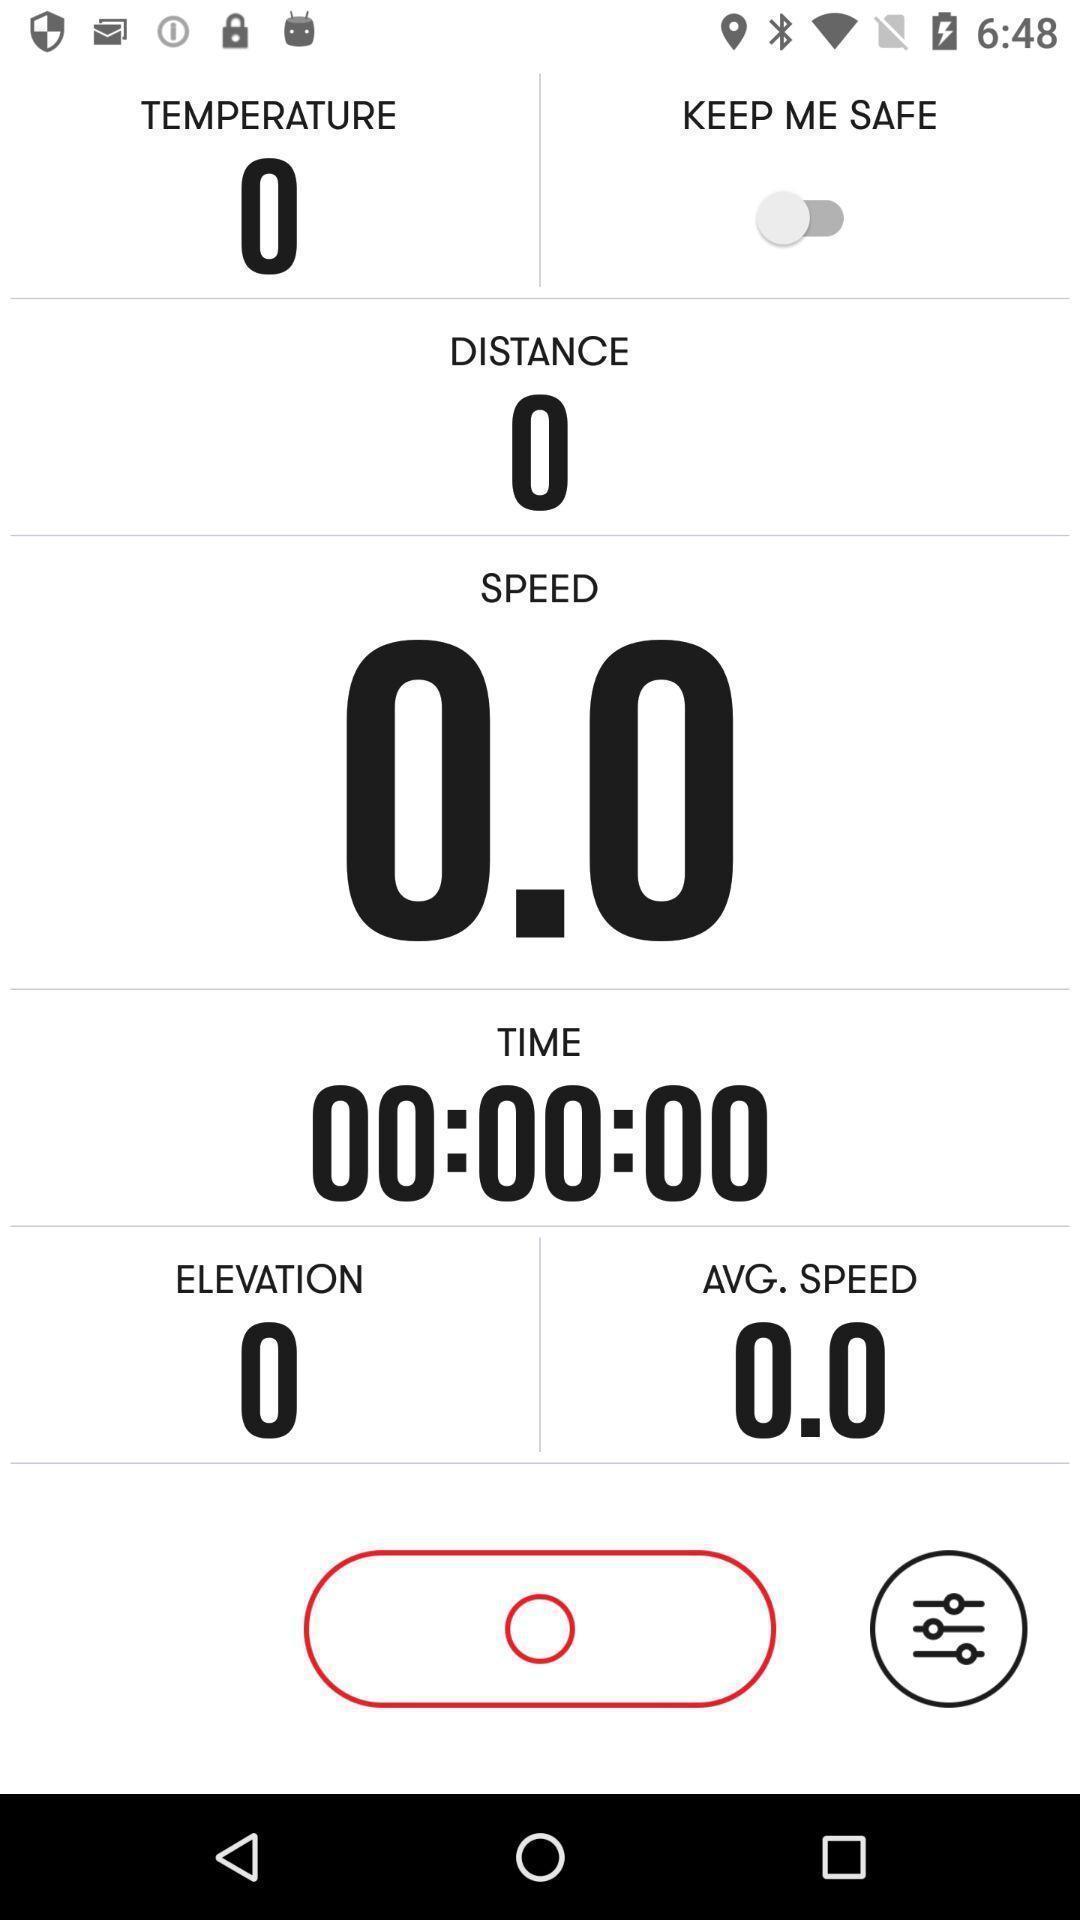Provide a detailed account of this screenshot. Screen shows multiple options in a speed application. 